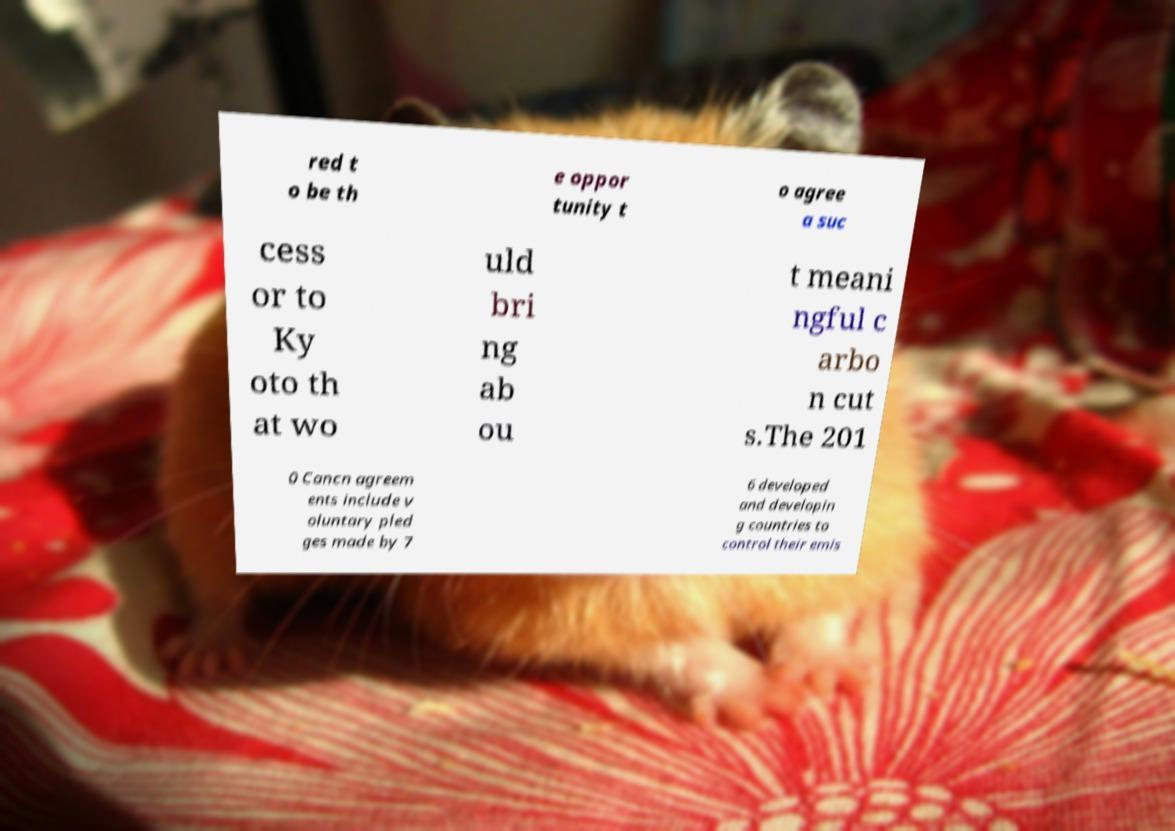For documentation purposes, I need the text within this image transcribed. Could you provide that? red t o be th e oppor tunity t o agree a suc cess or to Ky oto th at wo uld bri ng ab ou t meani ngful c arbo n cut s.The 201 0 Cancn agreem ents include v oluntary pled ges made by 7 6 developed and developin g countries to control their emis 